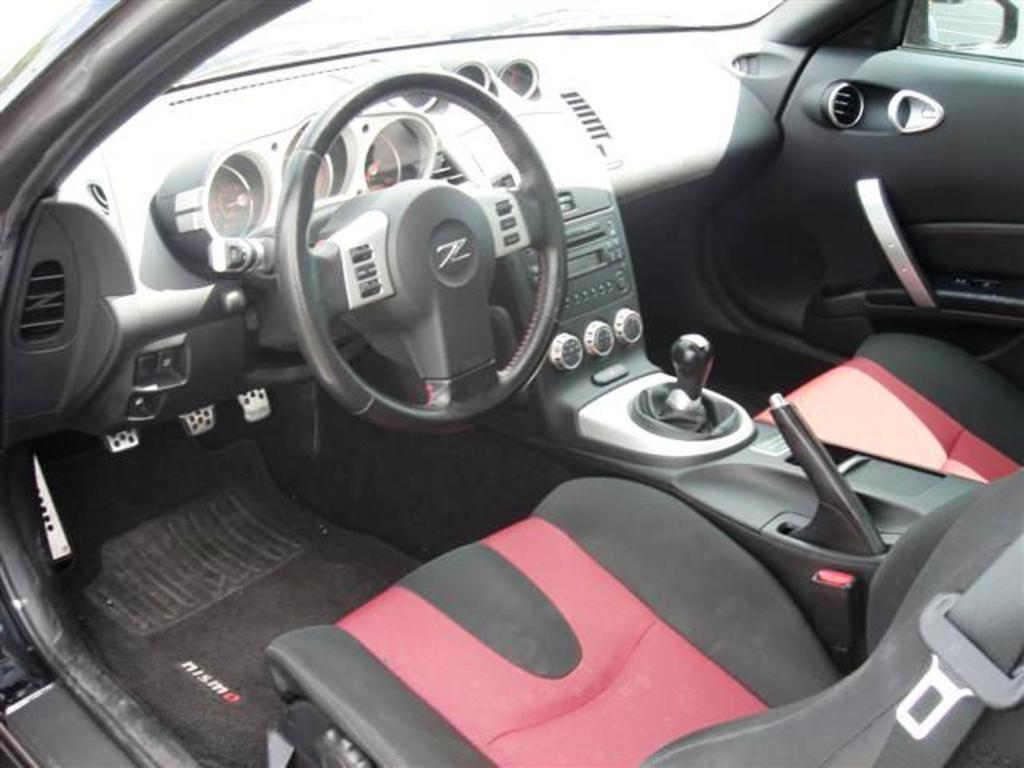What type of space is depicted in the image? The image shows an internal view of a vehicle. What can be found inside the vehicle? There is a seat and a steering wheel visible in the image. What part of the vehicle is used for controlling its direction? The steering wheel is used for controlling the direction of the vehicle. What other component is present in the image? The dashboard is present in the image. How many bears are sitting on the seat in the image? There are no bears present in the image; it shows an internal view of a vehicle with a seat, steering wheel, and dashboard. 